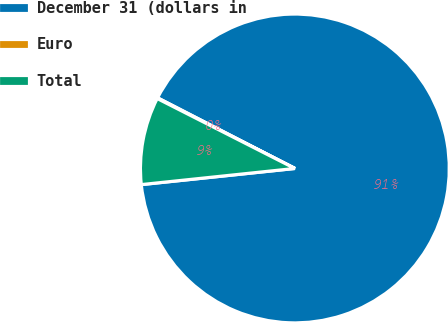Convert chart. <chart><loc_0><loc_0><loc_500><loc_500><pie_chart><fcel>December 31 (dollars in<fcel>Euro<fcel>Total<nl><fcel>90.78%<fcel>0.08%<fcel>9.15%<nl></chart> 